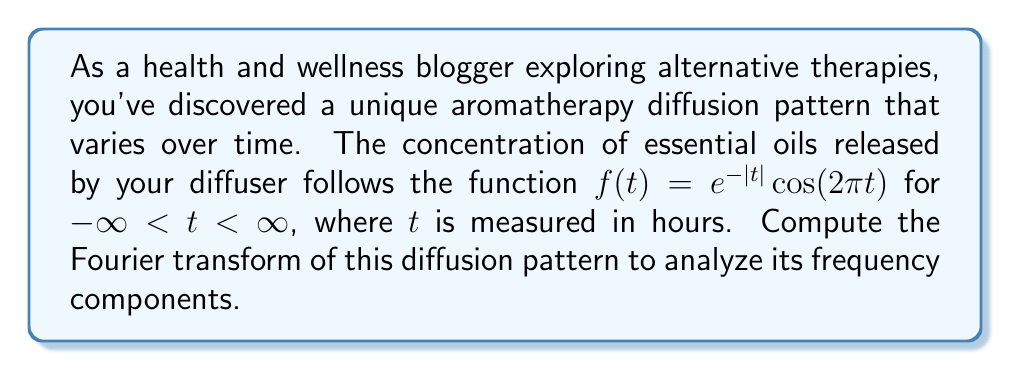What is the answer to this math problem? To compute the Fourier transform of the given function, we'll follow these steps:

1) The Fourier transform is defined as:
   $$F(\omega) = \int_{-\infty}^{\infty} f(t) e^{-i\omega t} dt$$

2) Substituting our function $f(t) = e^{-|t|}\cos(2\pi t)$:
   $$F(\omega) = \int_{-\infty}^{\infty} e^{-|t|}\cos(2\pi t) e^{-i\omega t} dt$$

3) Using Euler's formula, $\cos(2\pi t) = \frac{1}{2}(e^{2\pi i t} + e^{-2\pi i t})$:
   $$F(\omega) = \frac{1}{2}\int_{-\infty}^{\infty} e^{-|t|}(e^{2\pi i t} + e^{-2\pi i t}) e^{-i\omega t} dt$$

4) Simplifying:
   $$F(\omega) = \frac{1}{2}\int_{-\infty}^{\infty} e^{-|t|}(e^{i(2\pi-\omega)t} + e^{-i(2\pi+\omega)t}) dt$$

5) Split the integral into two parts:
   $$F(\omega) = \frac{1}{2}\int_{-\infty}^{0} e^{t}(e^{i(2\pi-\omega)t} + e^{-i(2\pi+\omega)t}) dt + \frac{1}{2}\int_{0}^{\infty} e^{-t}(e^{i(2\pi-\omega)t} + e^{-i(2\pi+\omega)t}) dt$$

6) Evaluate each integral:
   $$F(\omega) = \frac{1}{2}[\frac{1}{1-i(2\pi-\omega)} + \frac{1}{1+i(2\pi+\omega)} + \frac{1}{1+i(2\pi-\omega)} + \frac{1}{1-i(2\pi+\omega)}]$$

7) Find a common denominator and simplify:
   $$F(\omega) = \frac{1}{1+\omega^2-4\pi^2+4\pi i\omega}$$

8) This can be written in the form:
   $$F(\omega) = \frac{1+\omega^2-4\pi^2-4\pi i\omega}{(1+\omega^2-4\pi^2)^2+(4\pi\omega)^2}$$

This is the Fourier transform of the given aromatherapy diffusion pattern.
Answer: $$F(\omega) = \frac{1+\omega^2-4\pi^2-4\pi i\omega}{(1+\omega^2-4\pi^2)^2+(4\pi\omega)^2}$$ 